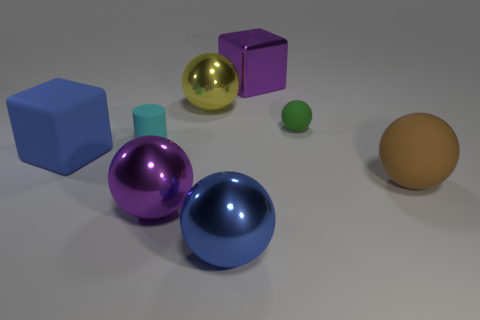Is there a red cylinder that has the same material as the big yellow ball?
Your answer should be very brief. No. What shape is the shiny object that is on the right side of the yellow sphere and behind the purple metal ball?
Ensure brevity in your answer.  Cube. How many tiny objects are either purple shiny spheres or cyan rubber cubes?
Offer a terse response. 0. What material is the brown sphere?
Offer a terse response. Rubber. How many other things are there of the same shape as the brown thing?
Your response must be concise. 4. How big is the cyan rubber cylinder?
Provide a short and direct response. Small. How big is the rubber object that is to the right of the cyan cylinder and to the left of the big brown rubber thing?
Make the answer very short. Small. What shape is the purple thing that is on the right side of the blue metal thing?
Offer a very short reply. Cube. Is the material of the small sphere the same as the yellow ball that is to the left of the tiny sphere?
Offer a very short reply. No. Do the tiny cyan matte object and the brown rubber thing have the same shape?
Ensure brevity in your answer.  No. 